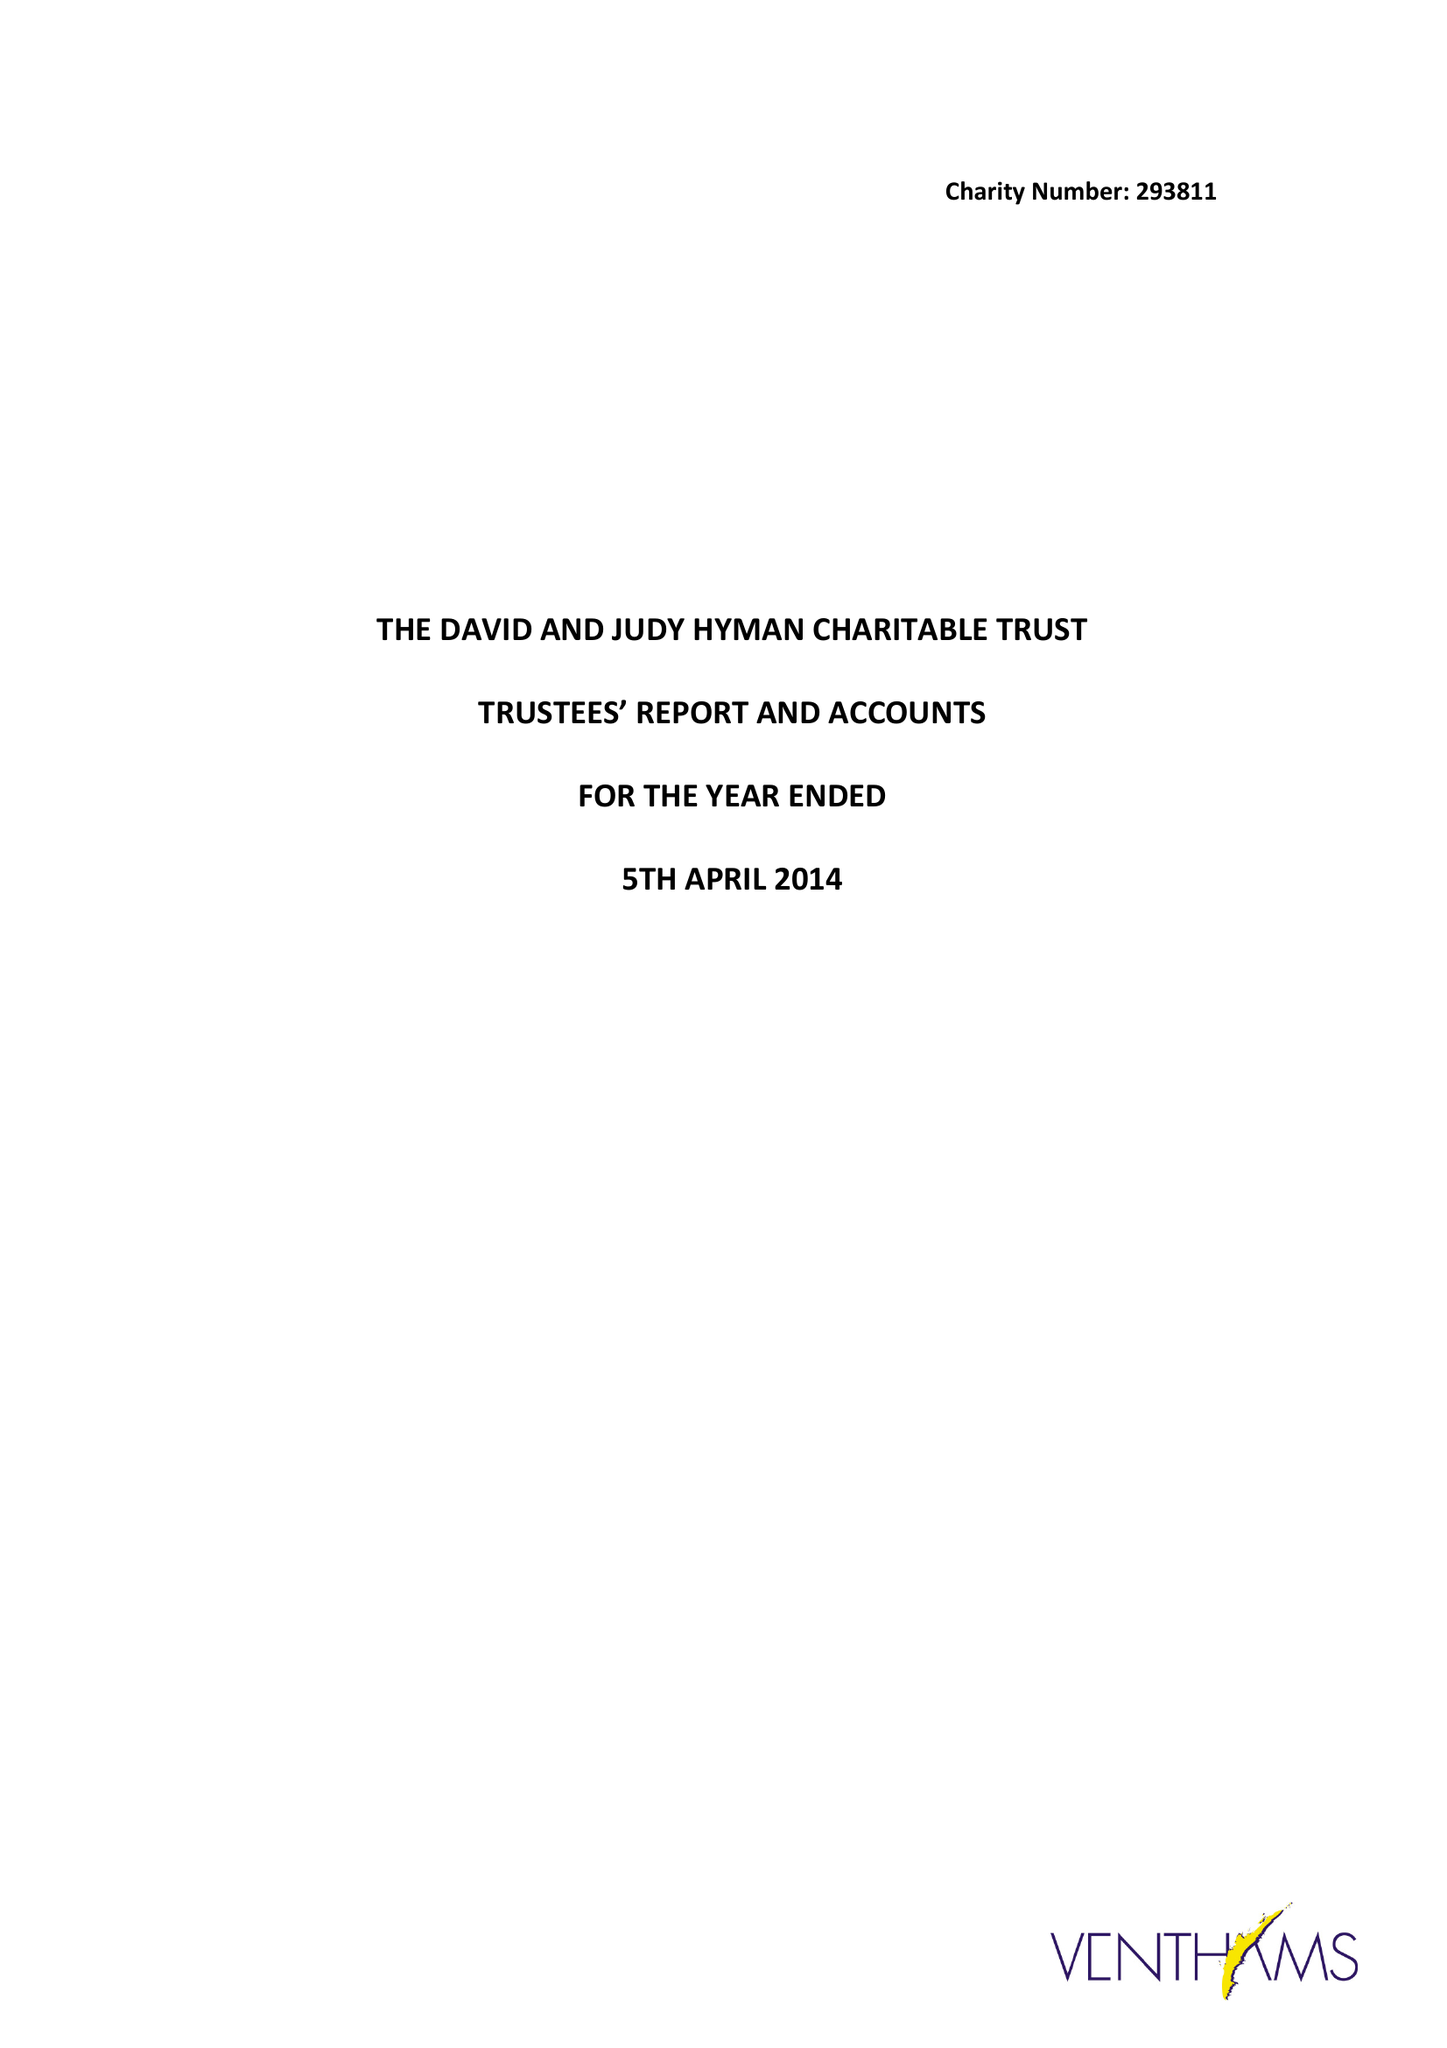What is the value for the address__street_line?
Answer the question using a single word or phrase. 7 MEADWAY CLOSE 